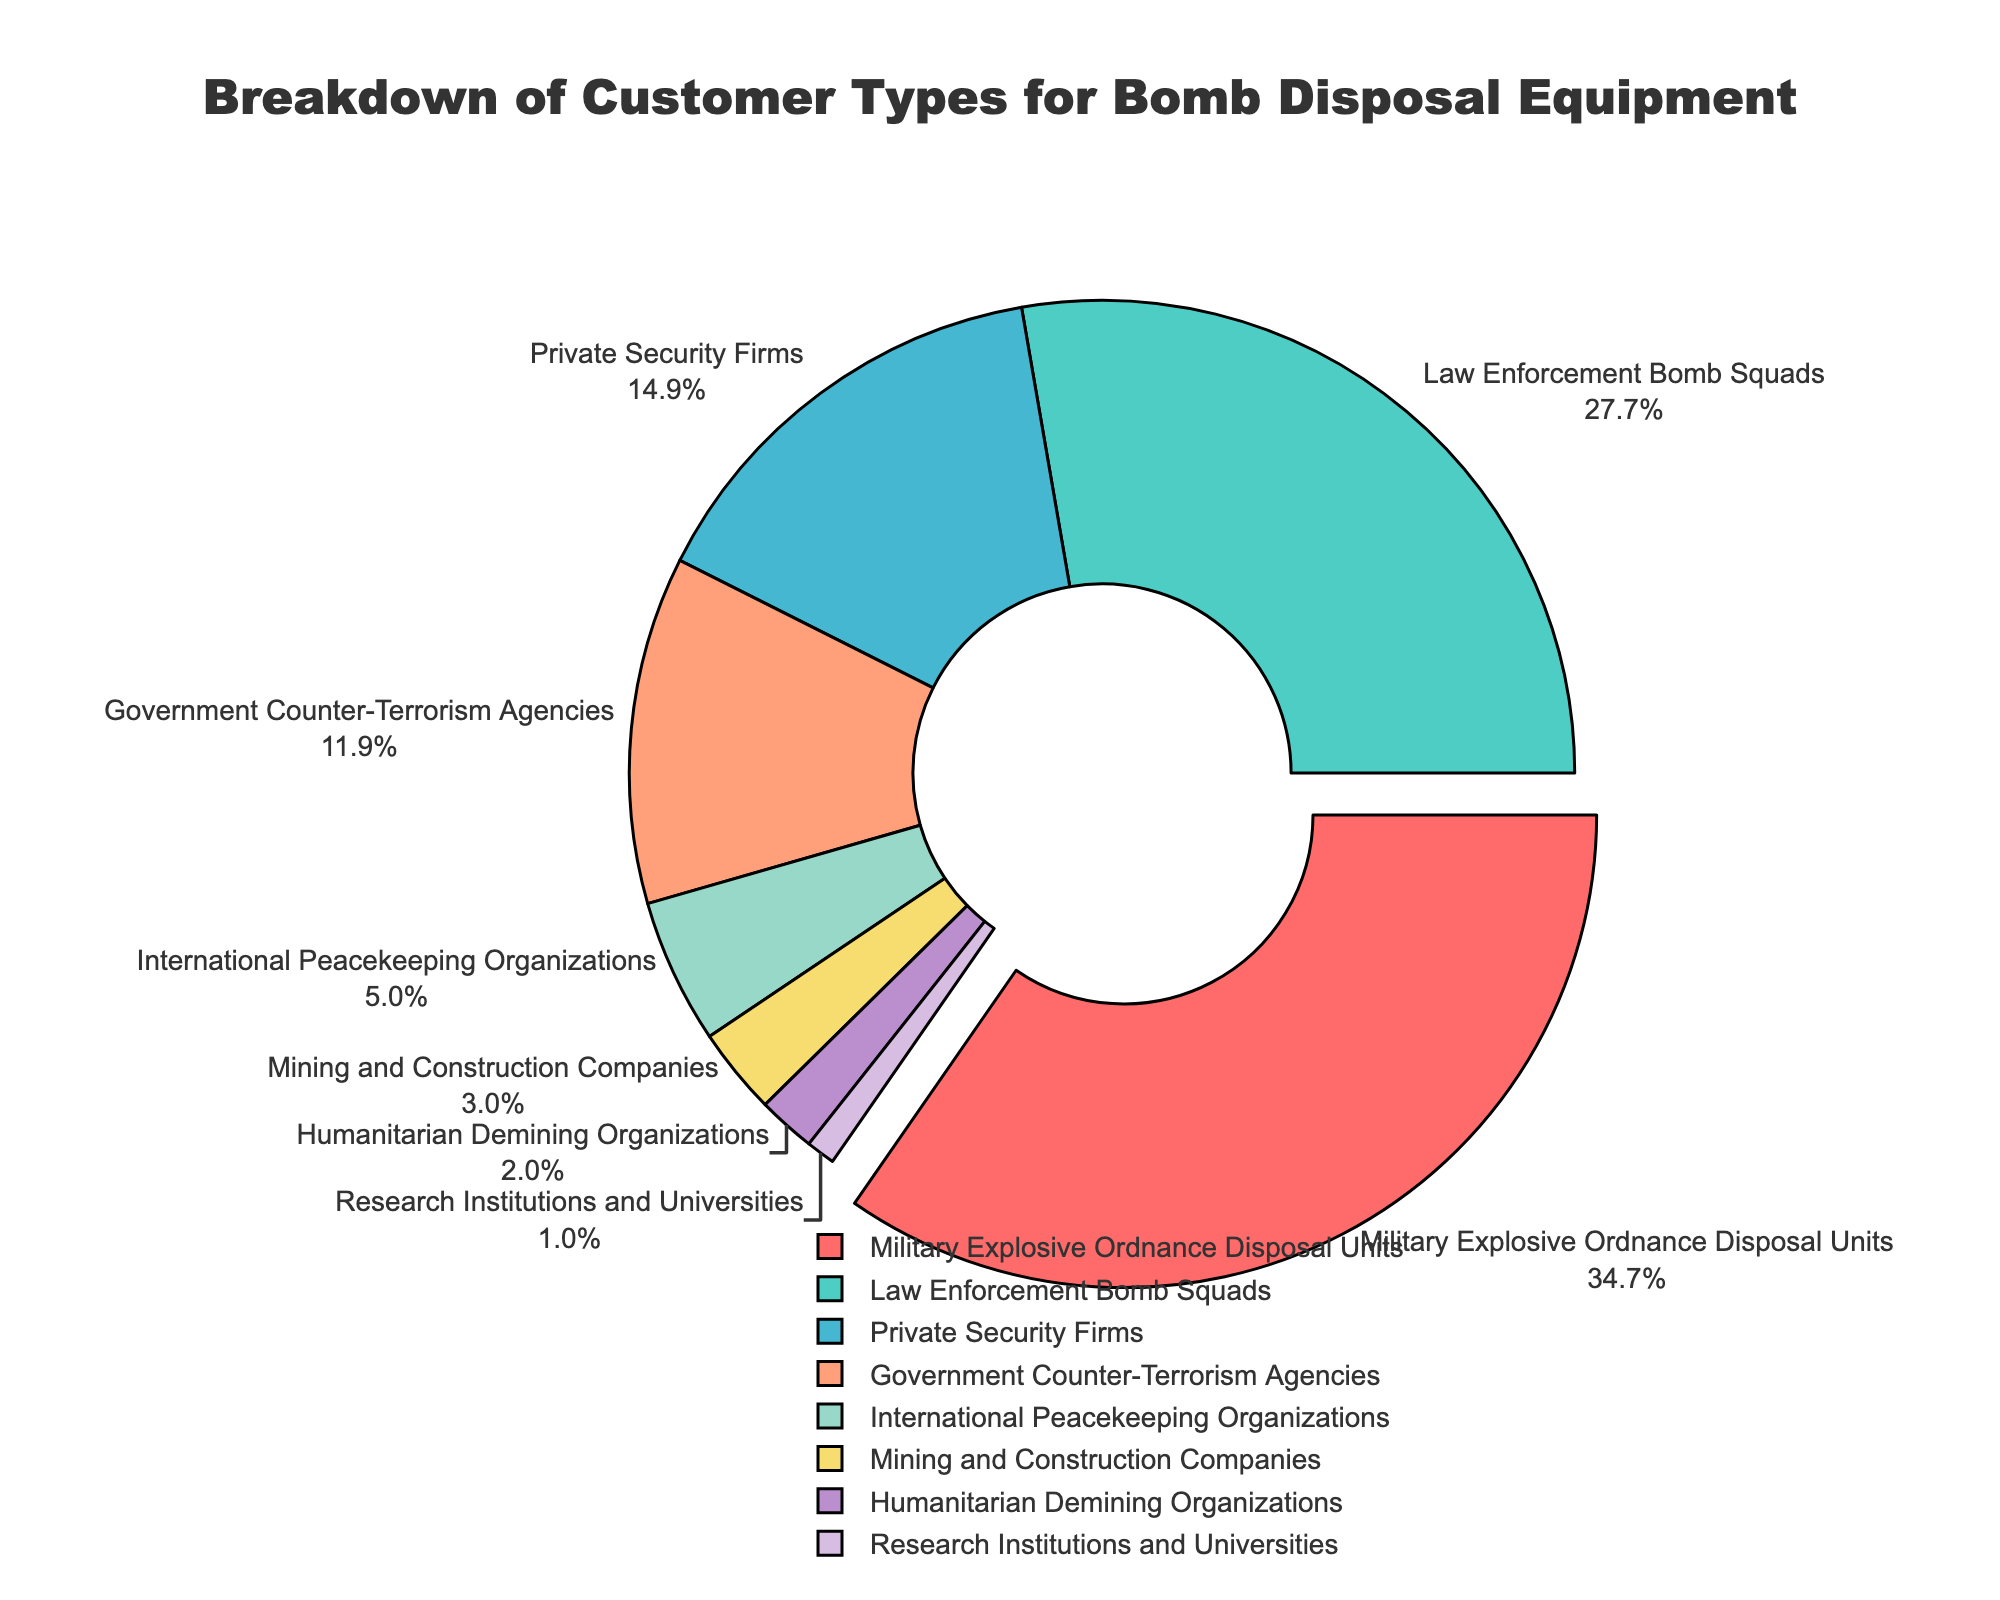Which category forms the largest segment in the pie chart? By visually assessing the pie chart, the largest segment is pulled out slightly and labeled with its percentage. The "Military Explosive Ordnance Disposal Units" category is the largest with 35%.
Answer: Military Explosive Ordnance Disposal Units How much larger is the percentage of Law Enforcement Bomb Squads compared to Government Counter-Terrorism Agencies? The segment for Law Enforcement Bomb Squads shows 28%, and the segment for Government Counter-Terrorism Agencies shows 12%. The difference is 28% - 12% = 16%.
Answer: 16% Which two categories combined make up the smallest percentage? The smallest segments are visible by their size and label. Adding the percentages of "Research Institutions and Universities" (1%) and "Humanitarian Demining Organizations" (2%) gives 1% + 2% = 3%.
Answer: Research Institutions and Universities and Humanitarian Demining Organizations What percentage of the pie chart is attributed to non-Military and non-Law Enforcement categories? The sum of all categories except "Military Explosive Ordnance Disposal Units" (35%) and "Law Enforcement Bomb Squads" (28%) is required. Summing the remaining categories: 15% + 12% + 5% + 3% + 2% + 1% = 38%.
Answer: 38% What is the ratio of the percentage of Private Security Firms to the percentage of International Peacekeeping Organizations? The segment for Private Security Firms is labeled as 15%, and International Peacekeeping Organizations is labeled as 5%. The ratio is 15% / 5% = 3:1.
Answer: 3:1 Which category is visually represented by the segment immediately following the pulled out segment? The code snippet rotates the pie chart by 90 degrees and pulls out the largest segment (Military Explosive Ordnance Disposal Units) slightly. The next segment in clockwise order is "Law Enforcement Bomb Squads" labeled with 28%.
Answer: Law Enforcement Bomb Squads If you were to combine the percentages of Government Counter-Terrorism Agencies and Mining and Construction Companies, would the resulting percentage be more, less, or equal to that of Law Enforcement Bomb Squads? Government Counter-Terrorism Agencies and Mining and Construction Companies together add to 12% + 3% = 15%. Law Enforcement Bomb Squads is 28%. 15% is less than 28%.
Answer: Less What fraction of the pie chart is represented by Military Explosive Ordnance Disposal Units and Humanitarian Demining Organizations together? Add the percentages of Military Explosive Ordnance Disposal Units (35%) and Humanitarian Demining Organizations (2%), then convert to a fraction: (35 + 2)/100 = 37/100 = 37/100.
Answer: 37/100 